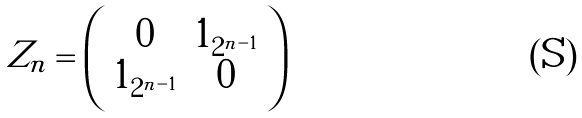Convert formula to latex. <formula><loc_0><loc_0><loc_500><loc_500>Z _ { n } = \left ( \begin{array} { c c } 0 & 1 _ { 2 ^ { n - 1 } } \\ 1 _ { 2 ^ { n - 1 } } & 0 \\ \end{array} \right )</formula> 